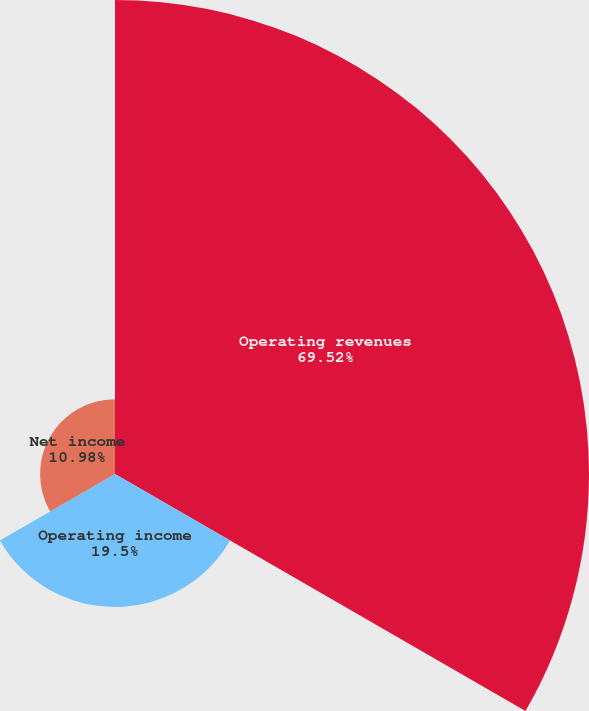<chart> <loc_0><loc_0><loc_500><loc_500><pie_chart><fcel>Operating revenues<fcel>Operating income<fcel>Net income<nl><fcel>69.52%<fcel>19.5%<fcel>10.98%<nl></chart> 